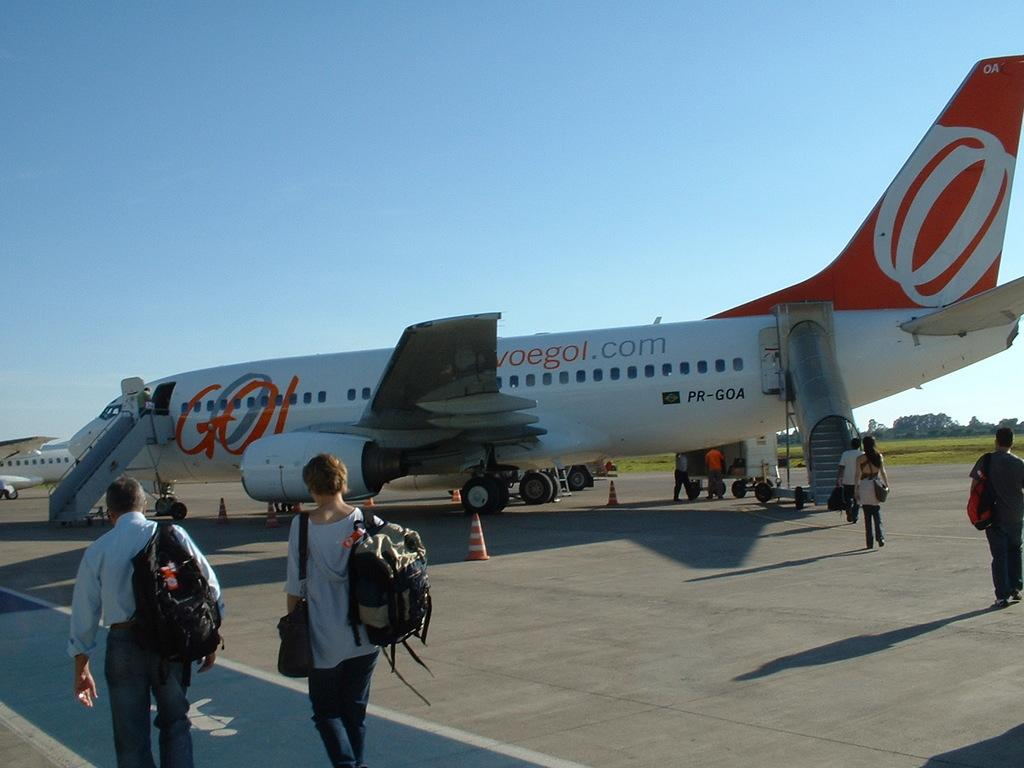<image>
Describe the image concisely. A white and orange plane has Voegol.com on the side. 